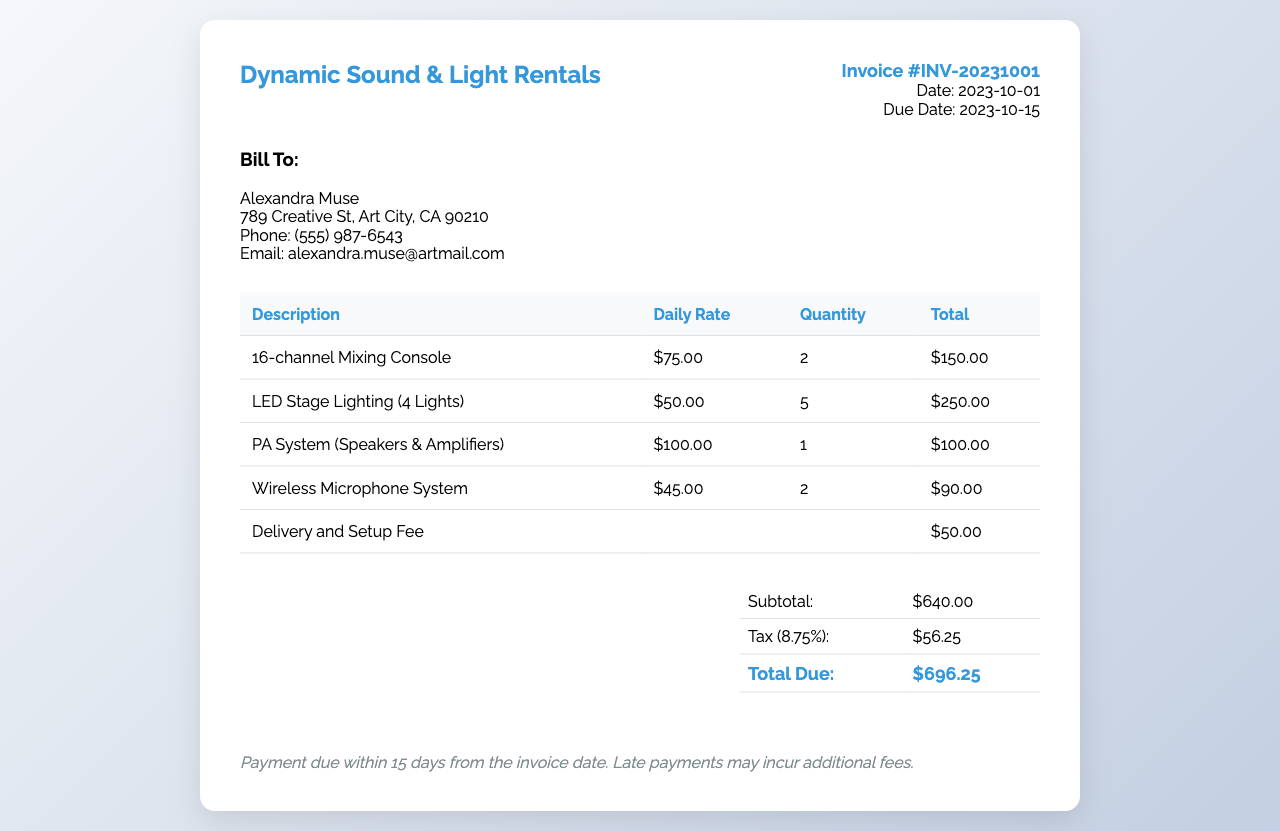what is the invoice number? The invoice number is listed at the top right corner of the document under "Invoice #".
Answer: INV-20231001 what is the total amount due? The total amount due is found in the summary table at the bottom of the document.
Answer: $696.25 how many 16-channel Mixing Consoles are rented? The quantity of the 16-channel Mixing Consoles is listed in the corresponding table row.
Answer: 2 what is the daily rate for the LED Stage Lighting? The daily rate is specified in the table next to the description of the item.
Answer: $50.00 what is the due date for payment? The due date is mentioned next to "Due Date" in the invoice details.
Answer: 2023-10-15 what is the subtotal before tax? The subtotal is provided in the summary table before any taxes are applied.
Answer: $640.00 how much is the delivery and setup fee? The delivery and setup fee is detailed in the table's last row under "Total".
Answer: $50.00 what percentage is the tax applied to the subtotal? The tax percentage is given in the summary section of the document.
Answer: 8.75% who is the invoice billed to? The name of the person the invoice is billed to is prominently displayed under "Bill To:".
Answer: Alexandra Muse 